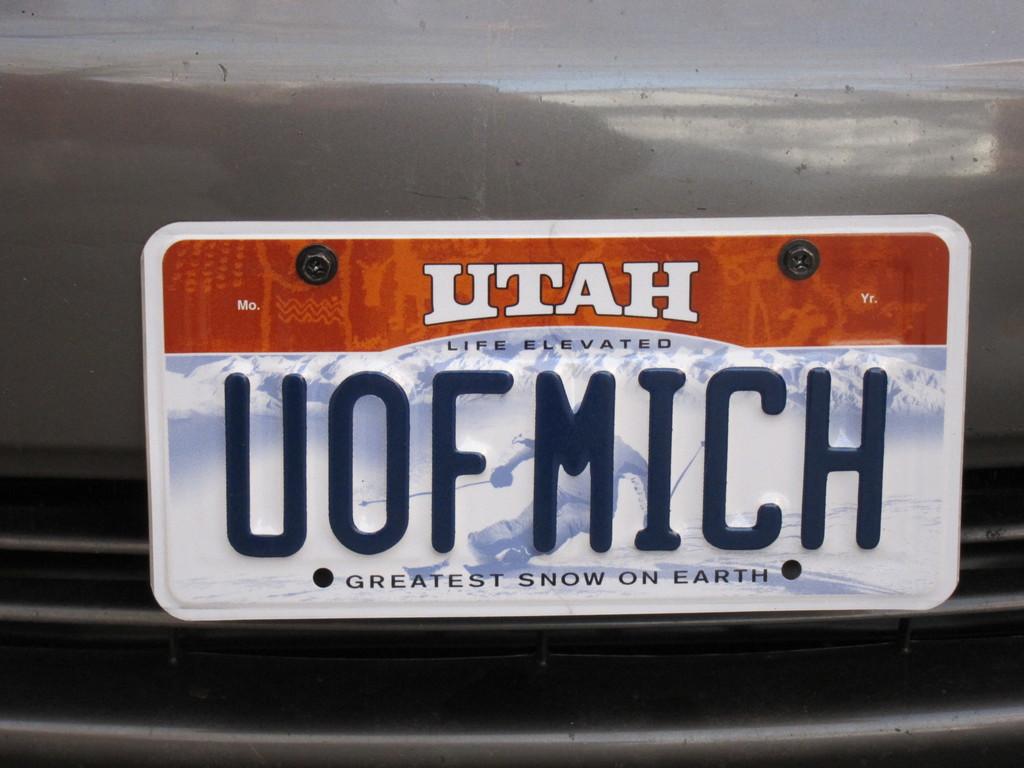What state does this license plate belong to?
Offer a terse response. Utah. What is the last line on the license plate?
Offer a terse response. Greatest snow on earth. 